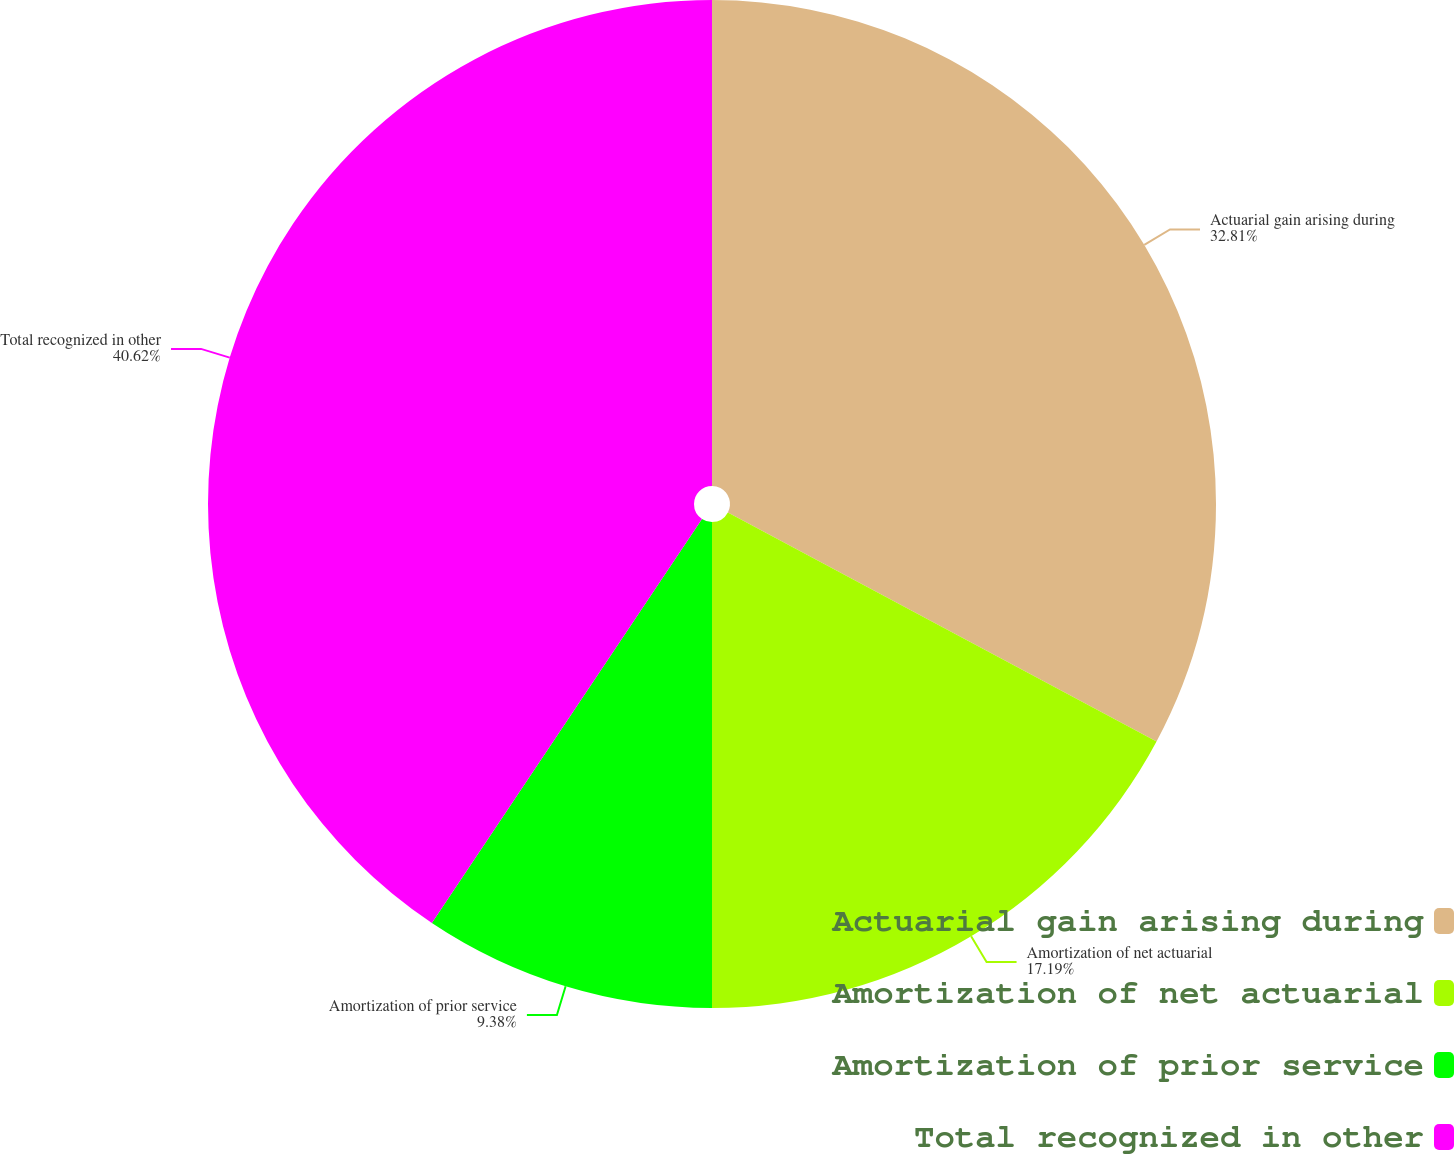Convert chart. <chart><loc_0><loc_0><loc_500><loc_500><pie_chart><fcel>Actuarial gain arising during<fcel>Amortization of net actuarial<fcel>Amortization of prior service<fcel>Total recognized in other<nl><fcel>32.81%<fcel>17.19%<fcel>9.38%<fcel>40.62%<nl></chart> 